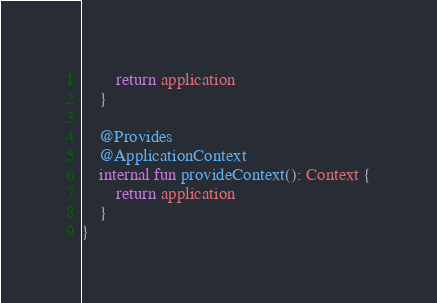Convert code to text. <code><loc_0><loc_0><loc_500><loc_500><_Kotlin_>        return application
    }

    @Provides
    @ApplicationContext
    internal fun provideContext(): Context {
        return application
    }
}</code> 